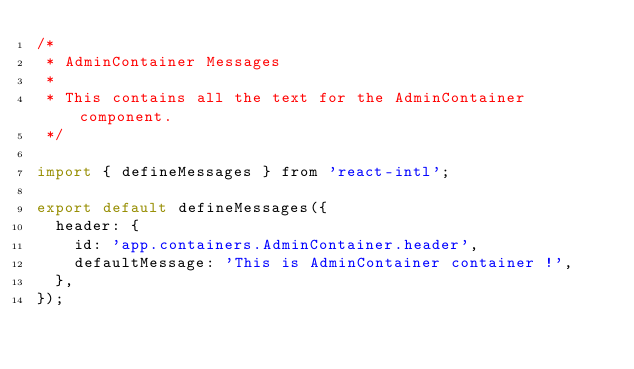Convert code to text. <code><loc_0><loc_0><loc_500><loc_500><_JavaScript_>/*
 * AdminContainer Messages
 *
 * This contains all the text for the AdminContainer component.
 */

import { defineMessages } from 'react-intl';

export default defineMessages({
  header: {
    id: 'app.containers.AdminContainer.header',
    defaultMessage: 'This is AdminContainer container !',
  },
});
</code> 